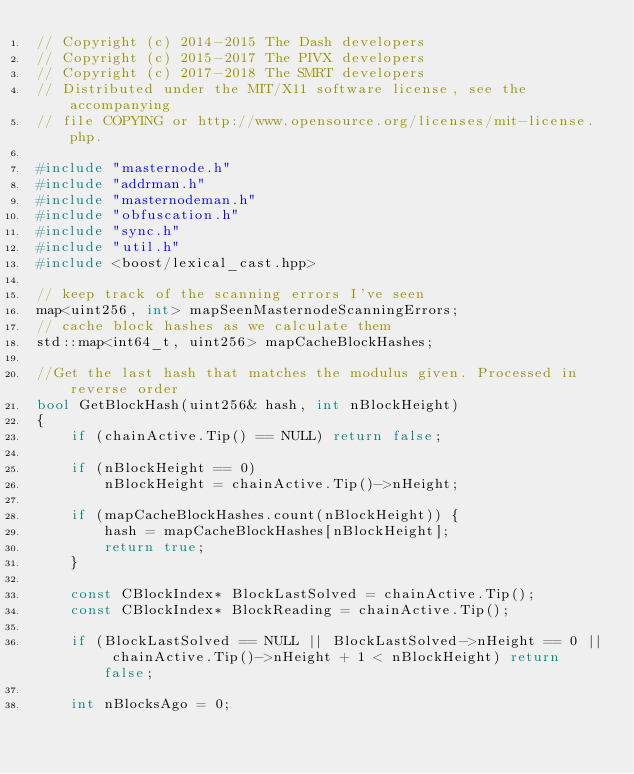<code> <loc_0><loc_0><loc_500><loc_500><_C++_>// Copyright (c) 2014-2015 The Dash developers
// Copyright (c) 2015-2017 The PIVX developers
// Copyright (c) 2017-2018 The SMRT developers
// Distributed under the MIT/X11 software license, see the accompanying
// file COPYING or http://www.opensource.org/licenses/mit-license.php.

#include "masternode.h"
#include "addrman.h"
#include "masternodeman.h"
#include "obfuscation.h"
#include "sync.h"
#include "util.h"
#include <boost/lexical_cast.hpp>

// keep track of the scanning errors I've seen
map<uint256, int> mapSeenMasternodeScanningErrors;
// cache block hashes as we calculate them
std::map<int64_t, uint256> mapCacheBlockHashes;

//Get the last hash that matches the modulus given. Processed in reverse order
bool GetBlockHash(uint256& hash, int nBlockHeight)
{
    if (chainActive.Tip() == NULL) return false;

    if (nBlockHeight == 0)
        nBlockHeight = chainActive.Tip()->nHeight;

    if (mapCacheBlockHashes.count(nBlockHeight)) {
        hash = mapCacheBlockHashes[nBlockHeight];
        return true;
    }

    const CBlockIndex* BlockLastSolved = chainActive.Tip();
    const CBlockIndex* BlockReading = chainActive.Tip();

    if (BlockLastSolved == NULL || BlockLastSolved->nHeight == 0 || chainActive.Tip()->nHeight + 1 < nBlockHeight) return false;

    int nBlocksAgo = 0;</code> 